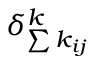<formula> <loc_0><loc_0><loc_500><loc_500>\delta _ { \sum { k _ { i j } } } ^ { k }</formula> 